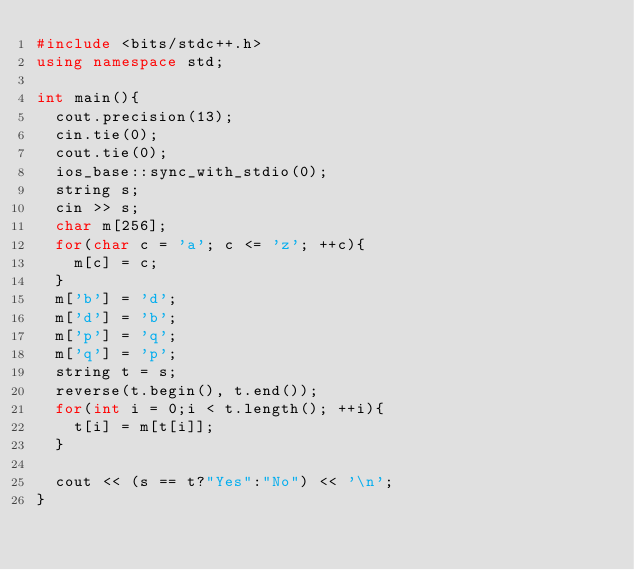Convert code to text. <code><loc_0><loc_0><loc_500><loc_500><_C++_>#include <bits/stdc++.h>
using namespace std;

int main(){
	cout.precision(13);
	cin.tie(0);
	cout.tie(0);
	ios_base::sync_with_stdio(0);
	string s;
	cin >> s;
	char m[256];
	for(char c = 'a'; c <= 'z'; ++c){
		m[c] = c;
	}
	m['b'] = 'd';
	m['d'] = 'b';
	m['p'] = 'q';
	m['q'] = 'p';
	string t = s;
	reverse(t.begin(), t.end());
	for(int i = 0;i < t.length(); ++i){
		t[i] = m[t[i]];
	}

	cout << (s == t?"Yes":"No") << '\n';
}
</code> 